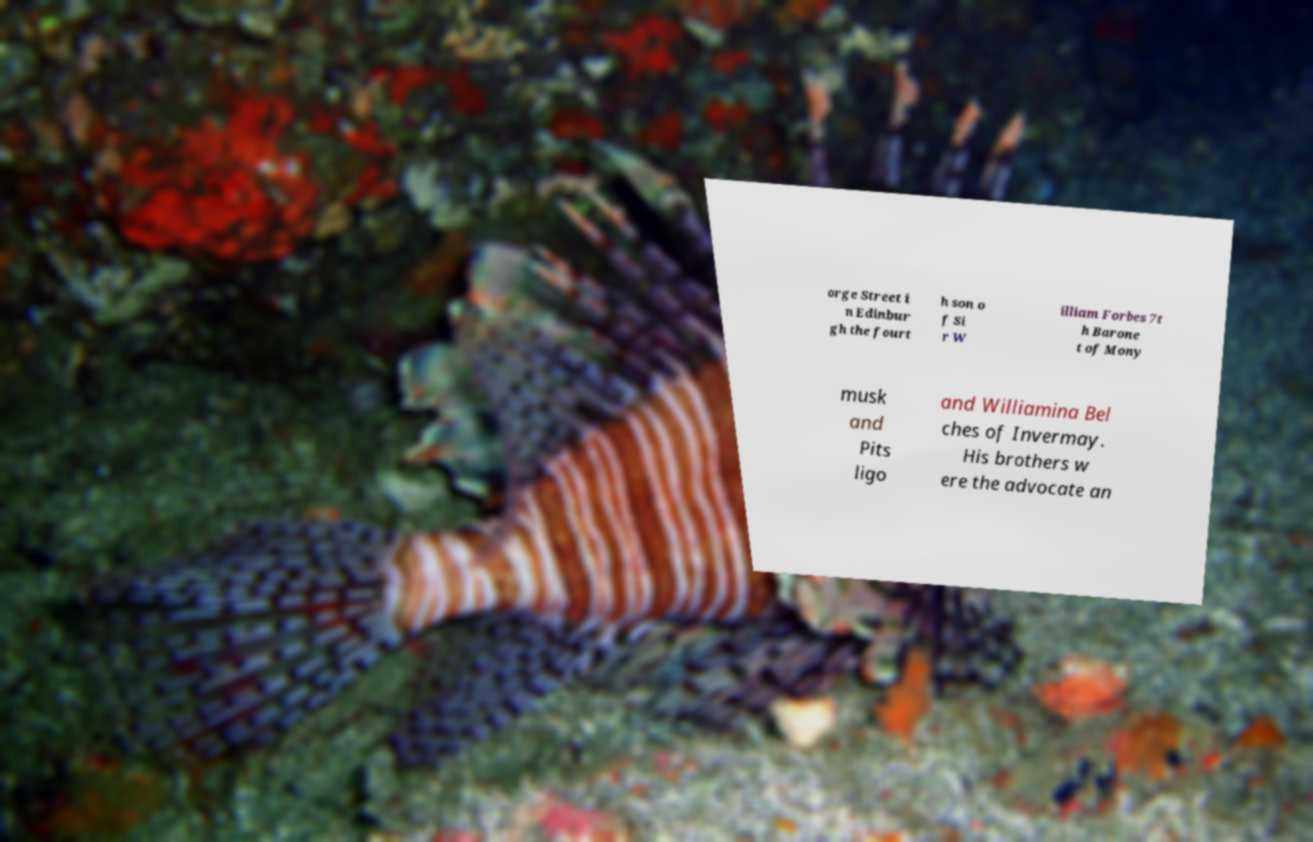Please read and relay the text visible in this image. What does it say? orge Street i n Edinbur gh the fourt h son o f Si r W illiam Forbes 7t h Barone t of Mony musk and Pits ligo and Williamina Bel ches of Invermay. His brothers w ere the advocate an 